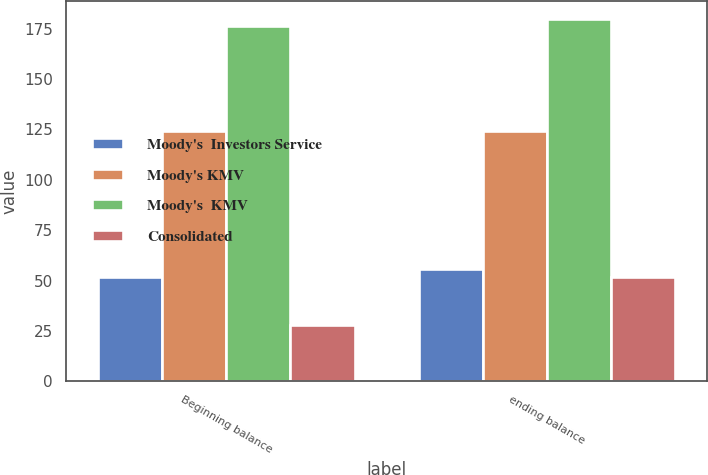Convert chart to OTSL. <chart><loc_0><loc_0><loc_500><loc_500><stacked_bar_chart><ecel><fcel>Beginning balance<fcel>ending balance<nl><fcel>Moody's  Investors Service<fcel>52<fcel>55.8<nl><fcel>Moody's KMV<fcel>124.1<fcel>124.1<nl><fcel>Moody's  KMV<fcel>176.1<fcel>179.9<nl><fcel>Consolidated<fcel>28<fcel>52<nl></chart> 